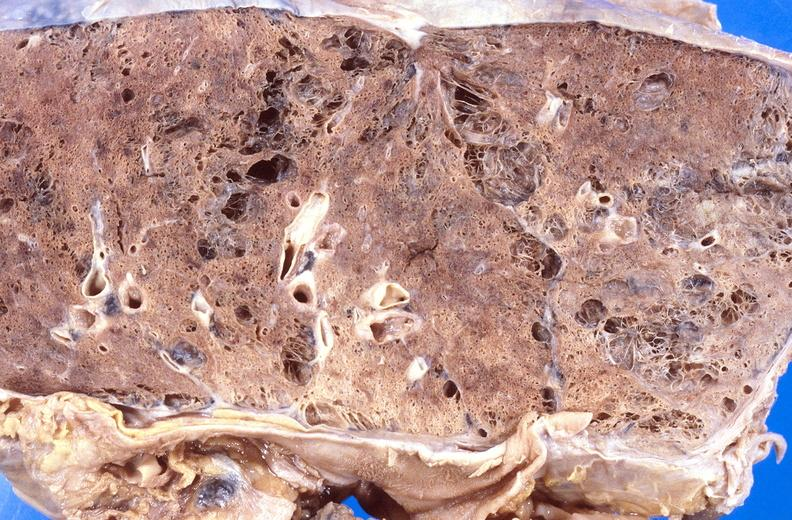what does this image show?
Answer the question using a single word or phrase. Cryptococcal pneumonia 